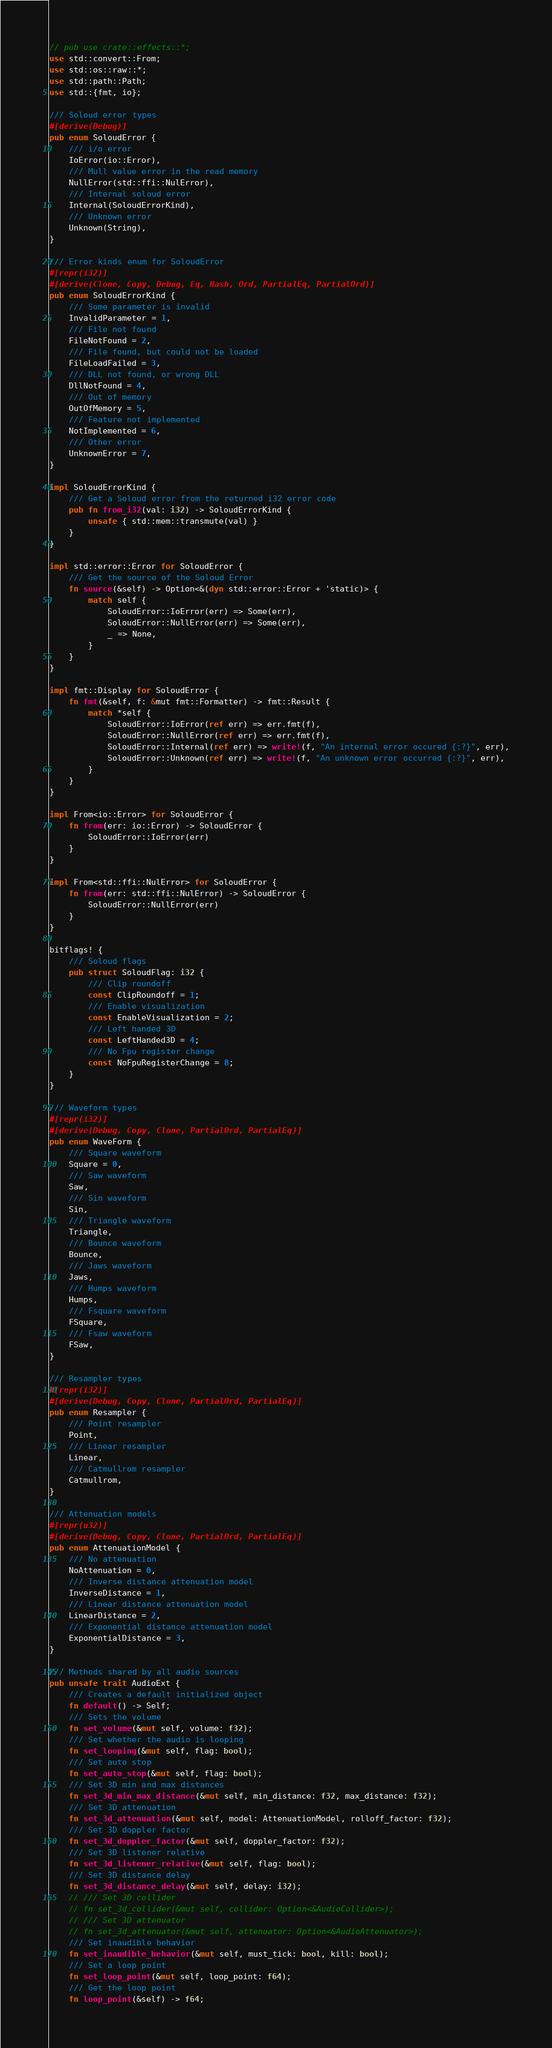<code> <loc_0><loc_0><loc_500><loc_500><_Rust_>// pub use crate::effects::*;
use std::convert::From;
use std::os::raw::*;
use std::path::Path;
use std::{fmt, io};

/// Soloud error types
#[derive(Debug)]
pub enum SoloudError {
    /// i/o error
    IoError(io::Error),
    /// Mull value error in the read memory
    NullError(std::ffi::NulError),
    /// Internal soloud error
    Internal(SoloudErrorKind),
    /// Unknown error
    Unknown(String),
}

/// Error kinds enum for SoloudError
#[repr(i32)]
#[derive(Clone, Copy, Debug, Eq, Hash, Ord, PartialEq, PartialOrd)]
pub enum SoloudErrorKind {
    /// Some parameter is invalid
    InvalidParameter = 1,
    /// File not found
    FileNotFound = 2,
    /// File found, but could not be loaded
    FileLoadFailed = 3,
    /// DLL not found, or wrong DLL
    DllNotFound = 4,
    /// Out of memory
    OutOfMemory = 5,
    /// Feature not implemented
    NotImplemented = 6,
    /// Other error   
    UnknownError = 7,
}

impl SoloudErrorKind {
    /// Get a Soloud error from the returned i32 error code
    pub fn from_i32(val: i32) -> SoloudErrorKind {
        unsafe { std::mem::transmute(val) }
    }
}

impl std::error::Error for SoloudError {
    /// Get the source of the Soloud Error
    fn source(&self) -> Option<&(dyn std::error::Error + 'static)> {
        match self {
            SoloudError::IoError(err) => Some(err),
            SoloudError::NullError(err) => Some(err),
            _ => None,
        }
    }
}

impl fmt::Display for SoloudError {
    fn fmt(&self, f: &mut fmt::Formatter) -> fmt::Result {
        match *self {
            SoloudError::IoError(ref err) => err.fmt(f),
            SoloudError::NullError(ref err) => err.fmt(f),
            SoloudError::Internal(ref err) => write!(f, "An internal error occured {:?}", err),
            SoloudError::Unknown(ref err) => write!(f, "An unknown error occurred {:?}", err),
        }
    }
}

impl From<io::Error> for SoloudError {
    fn from(err: io::Error) -> SoloudError {
        SoloudError::IoError(err)
    }
}

impl From<std::ffi::NulError> for SoloudError {
    fn from(err: std::ffi::NulError) -> SoloudError {
        SoloudError::NullError(err)
    }
}

bitflags! {
    /// Soloud flags
    pub struct SoloudFlag: i32 {
        /// Clip roundoff
        const ClipRoundoff = 1;
        /// Enable visualization
        const EnableVisualization = 2;
        /// Left handed 3D
        const LeftHanded3D = 4;
        /// No Fpu register change
        const NoFpuRegisterChange = 8;
    }
}

/// Waveform types
#[repr(i32)]
#[derive(Debug, Copy, Clone, PartialOrd, PartialEq)]
pub enum WaveForm {
    /// Square waveform
    Square = 0,
    /// Saw waveform
    Saw,
    /// Sin waveform
    Sin,
    /// Triangle waveform
    Triangle,
    /// Bounce waveform
    Bounce,
    /// Jaws waveform
    Jaws,
    /// Humps waveform
    Humps,
    /// Fsquare waveform
    FSquare,
    /// Fsaw waveform
    FSaw,
}

/// Resampler types
#[repr(i32)]
#[derive(Debug, Copy, Clone, PartialOrd, PartialEq)]
pub enum Resampler {
    /// Point resampler
    Point,
    /// Linear resampler
    Linear,
    /// Catmullrom resampler
    Catmullrom,
}

/// Attenuation models
#[repr(u32)]
#[derive(Debug, Copy, Clone, PartialOrd, PartialEq)]
pub enum AttenuationModel {
    /// No attenuation
    NoAttenuation = 0,
    /// Inverse distance attenuation model
    InverseDistance = 1,
    /// Linear distance attenuation model
    LinearDistance = 2,
    /// Exponential distance attenuation model
    ExponentialDistance = 3,
}

/// Methods shared by all audio sources
pub unsafe trait AudioExt {
    /// Creates a default initialized object
    fn default() -> Self;
    /// Sets the volume
    fn set_volume(&mut self, volume: f32);
    /// Set whether the audio is looping
    fn set_looping(&mut self, flag: bool);
    /// Set auto stop
    fn set_auto_stop(&mut self, flag: bool);
    /// Set 3D min and max distances
    fn set_3d_min_max_distance(&mut self, min_distance: f32, max_distance: f32);
    /// Set 3D attenuation
    fn set_3d_attenuation(&mut self, model: AttenuationModel, rolloff_factor: f32);
    /// Set 3D doppler factor
    fn set_3d_doppler_factor(&mut self, doppler_factor: f32);
    /// Set 3D listener relative
    fn set_3d_listener_relative(&mut self, flag: bool);
    /// Set 3D distance delay
    fn set_3d_distance_delay(&mut self, delay: i32);
    // /// Set 3D collider
    // fn set_3d_collider(&mut self, collider: Option<&AudioCollider>);
    // /// Set 3D attenuator
    // fn set_3d_attenuator(&mut self, attenuator: Option<&AudioAttenuator>);
    /// Set inaudible behavior
    fn set_inaudible_behavior(&mut self, must_tick: bool, kill: bool);
    /// Set a loop point
    fn set_loop_point(&mut self, loop_point: f64);
    /// Get the loop point
    fn loop_point(&self) -> f64;</code> 